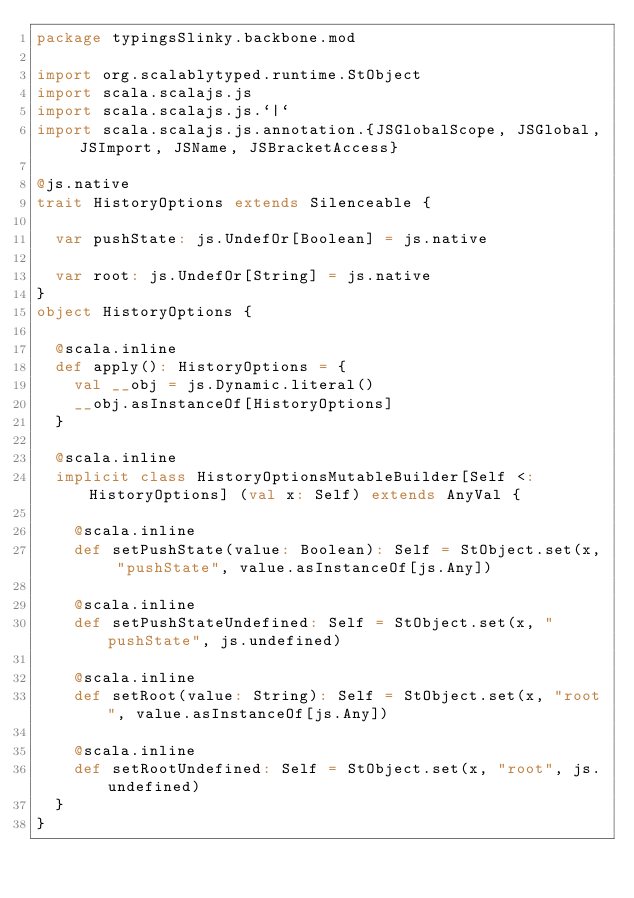<code> <loc_0><loc_0><loc_500><loc_500><_Scala_>package typingsSlinky.backbone.mod

import org.scalablytyped.runtime.StObject
import scala.scalajs.js
import scala.scalajs.js.`|`
import scala.scalajs.js.annotation.{JSGlobalScope, JSGlobal, JSImport, JSName, JSBracketAccess}

@js.native
trait HistoryOptions extends Silenceable {
  
  var pushState: js.UndefOr[Boolean] = js.native
  
  var root: js.UndefOr[String] = js.native
}
object HistoryOptions {
  
  @scala.inline
  def apply(): HistoryOptions = {
    val __obj = js.Dynamic.literal()
    __obj.asInstanceOf[HistoryOptions]
  }
  
  @scala.inline
  implicit class HistoryOptionsMutableBuilder[Self <: HistoryOptions] (val x: Self) extends AnyVal {
    
    @scala.inline
    def setPushState(value: Boolean): Self = StObject.set(x, "pushState", value.asInstanceOf[js.Any])
    
    @scala.inline
    def setPushStateUndefined: Self = StObject.set(x, "pushState", js.undefined)
    
    @scala.inline
    def setRoot(value: String): Self = StObject.set(x, "root", value.asInstanceOf[js.Any])
    
    @scala.inline
    def setRootUndefined: Self = StObject.set(x, "root", js.undefined)
  }
}
</code> 